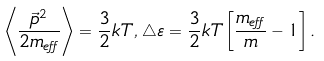Convert formula to latex. <formula><loc_0><loc_0><loc_500><loc_500>\left \langle \frac { \vec { p } ^ { 2 } } { 2 m _ { e f f } } \right \rangle = \frac { 3 } { 2 } k T , \, \triangle \varepsilon = \frac { 3 } { 2 } k T \left [ \frac { m _ { e f f } } { m } - 1 \right ] .</formula> 